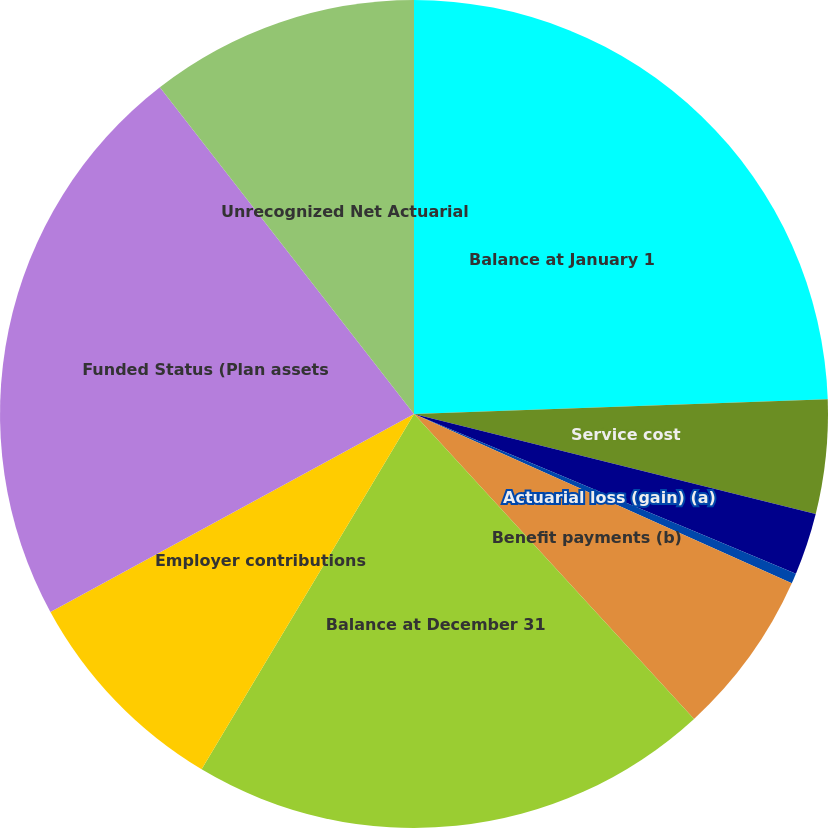Convert chart. <chart><loc_0><loc_0><loc_500><loc_500><pie_chart><fcel>Balance at January 1<fcel>Service cost<fcel>Interest cost<fcel>Actuarial loss (gain) (a)<fcel>Benefit payments (b)<fcel>Balance at December 31<fcel>Employer contributions<fcel>Funded Status (Plan assets<fcel>Unrecognized Net Actuarial<nl><fcel>24.44%<fcel>4.45%<fcel>2.42%<fcel>0.4%<fcel>6.47%<fcel>20.4%<fcel>8.49%<fcel>22.42%<fcel>10.52%<nl></chart> 